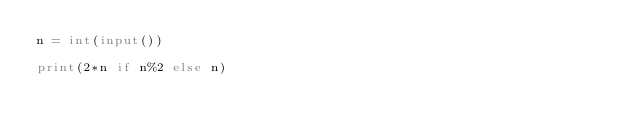<code> <loc_0><loc_0><loc_500><loc_500><_Python_>n = int(input())

print(2*n if n%2 else n)</code> 